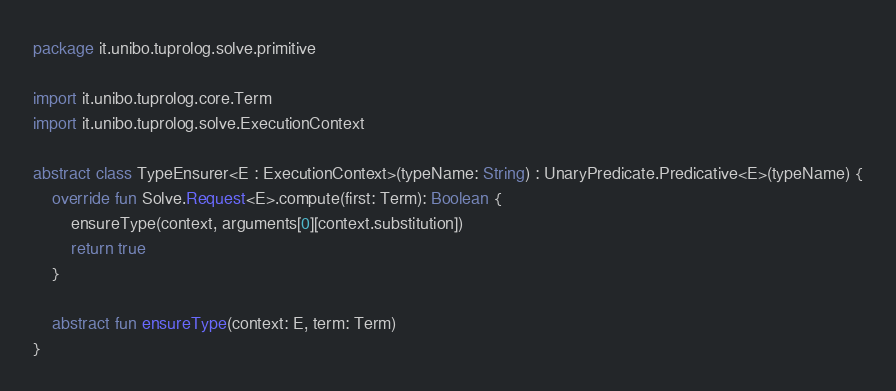Convert code to text. <code><loc_0><loc_0><loc_500><loc_500><_Kotlin_>package it.unibo.tuprolog.solve.primitive

import it.unibo.tuprolog.core.Term
import it.unibo.tuprolog.solve.ExecutionContext

abstract class TypeEnsurer<E : ExecutionContext>(typeName: String) : UnaryPredicate.Predicative<E>(typeName) {
    override fun Solve.Request<E>.compute(first: Term): Boolean {
        ensureType(context, arguments[0][context.substitution])
        return true
    }

    abstract fun ensureType(context: E, term: Term)
}</code> 